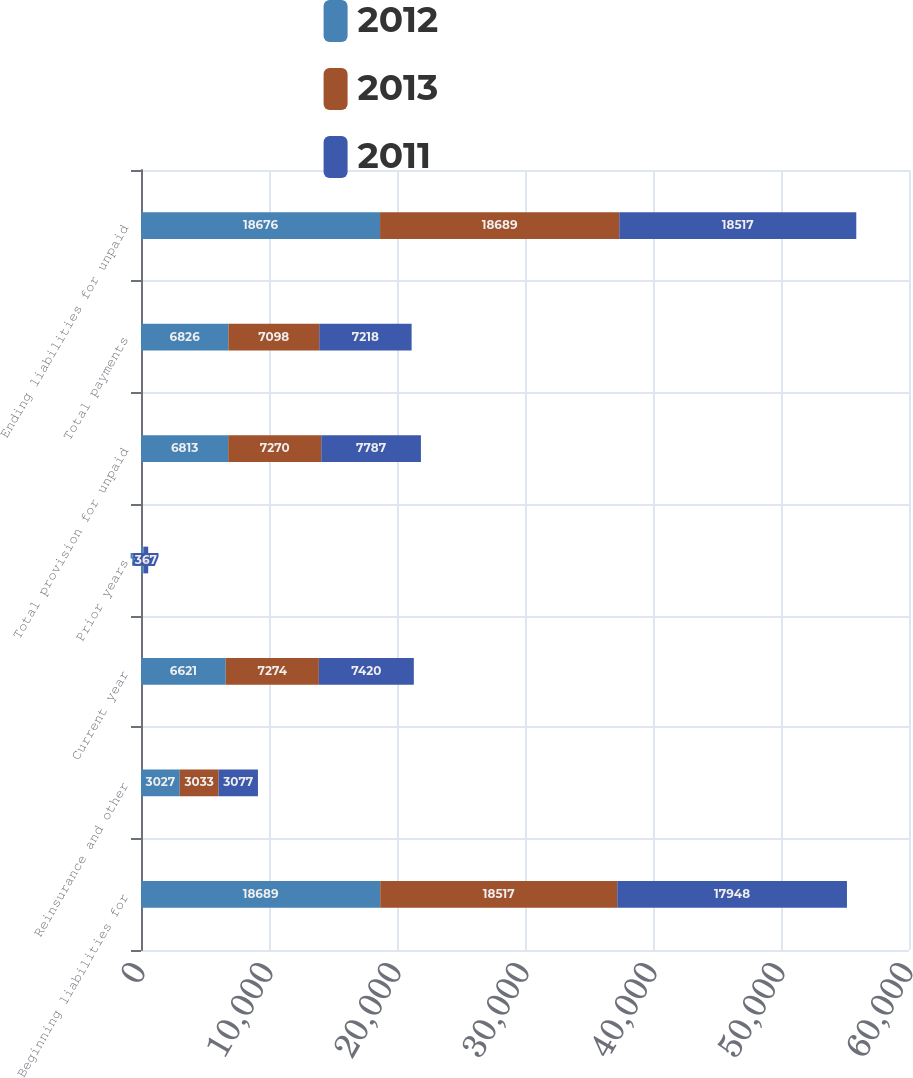<chart> <loc_0><loc_0><loc_500><loc_500><stacked_bar_chart><ecel><fcel>Beginning liabilities for<fcel>Reinsurance and other<fcel>Current year<fcel>Prior years<fcel>Total provision for unpaid<fcel>Total payments<fcel>Ending liabilities for unpaid<nl><fcel>2012<fcel>18689<fcel>3027<fcel>6621<fcel>192<fcel>6813<fcel>6826<fcel>18676<nl><fcel>2013<fcel>18517<fcel>3033<fcel>7274<fcel>4<fcel>7270<fcel>7098<fcel>18689<nl><fcel>2011<fcel>17948<fcel>3077<fcel>7420<fcel>367<fcel>7787<fcel>7218<fcel>18517<nl></chart> 